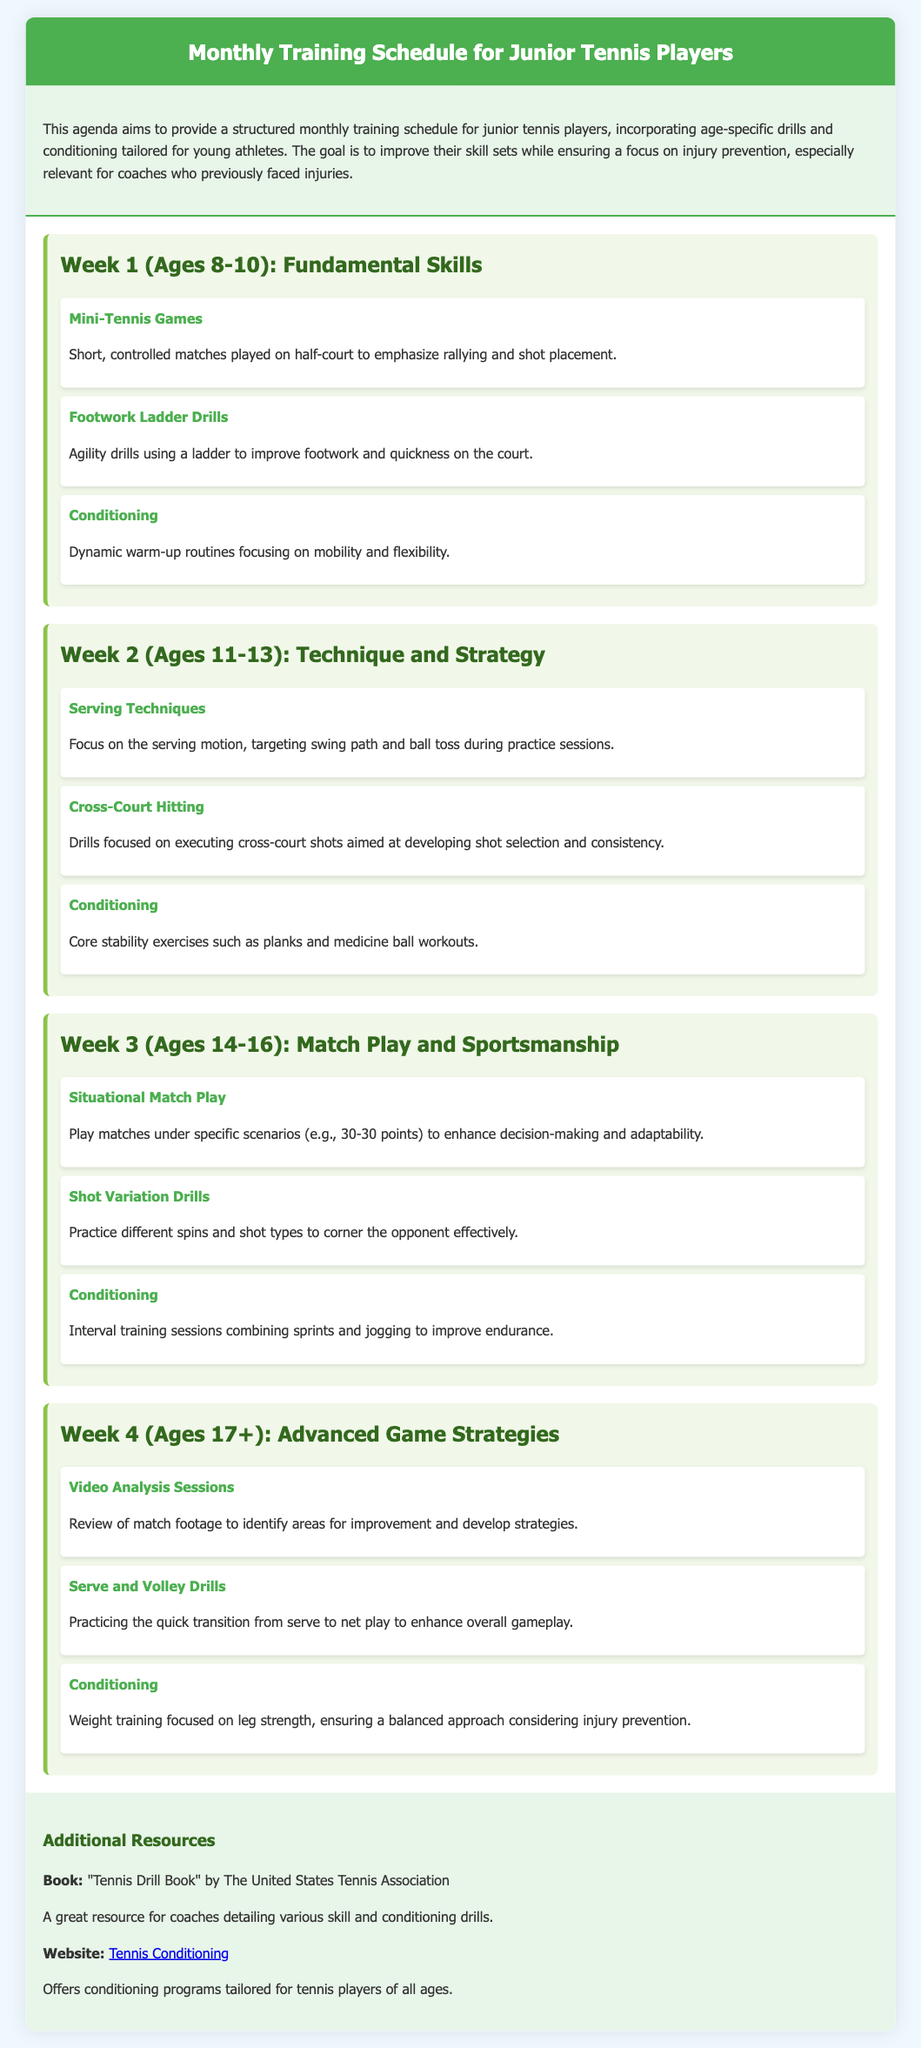What is the title of the document? The title of the document is given in the header section at the top of the page.
Answer: Monthly Training Schedule for Junior Tennis Players How many weeks are outlined in the schedule? The document specifically organizes the agenda into four distinct weekly sections based on age groups.
Answer: 4 What age group focuses on Fundamental Skills? The week focuses on developing essential tennis skills for younger players.
Answer: Ages 8-10 What type of drill is emphasized in Week 2? The second week includes drills that target a specific skill set, as indicated in the drills section.
Answer: Serving Techniques What is an example of conditioning in Week 3? The conditioning activity listed here helps enhance physical performance relevant to playing tennis for teenagers.
Answer: Interval training sessions How many age groups are included in the training schedule? The document mentions specific age categories for each weekly section, indicating separate training focuses.
Answer: 4 Which week includes Video Analysis Sessions? The week corresponds to a more advanced skill set aimed at older players, highlighting strategic improvement.
Answer: Week 4 What is the focus of the conditioning in Week 1? The first week emphasizes warm-up routines that prepare young players’ bodies for physical activity and prevent injuries.
Answer: Dynamic warm-up routines What additional resource is suggested in the document? This resource provides coaches with various tools to enhance training and conditioning strategies for their players.
Answer: "Tennis Drill Book" by The United States Tennis Association 